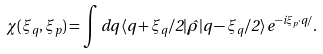Convert formula to latex. <formula><loc_0><loc_0><loc_500><loc_500>\chi ( \xi _ { q } , \xi _ { p } ) = \int d q \, \langle q + \xi _ { q } / 2 | \hat { \rho } | q - \xi _ { q } / 2 \rangle \, e ^ { - i \xi _ { p } \cdot q / } .</formula> 